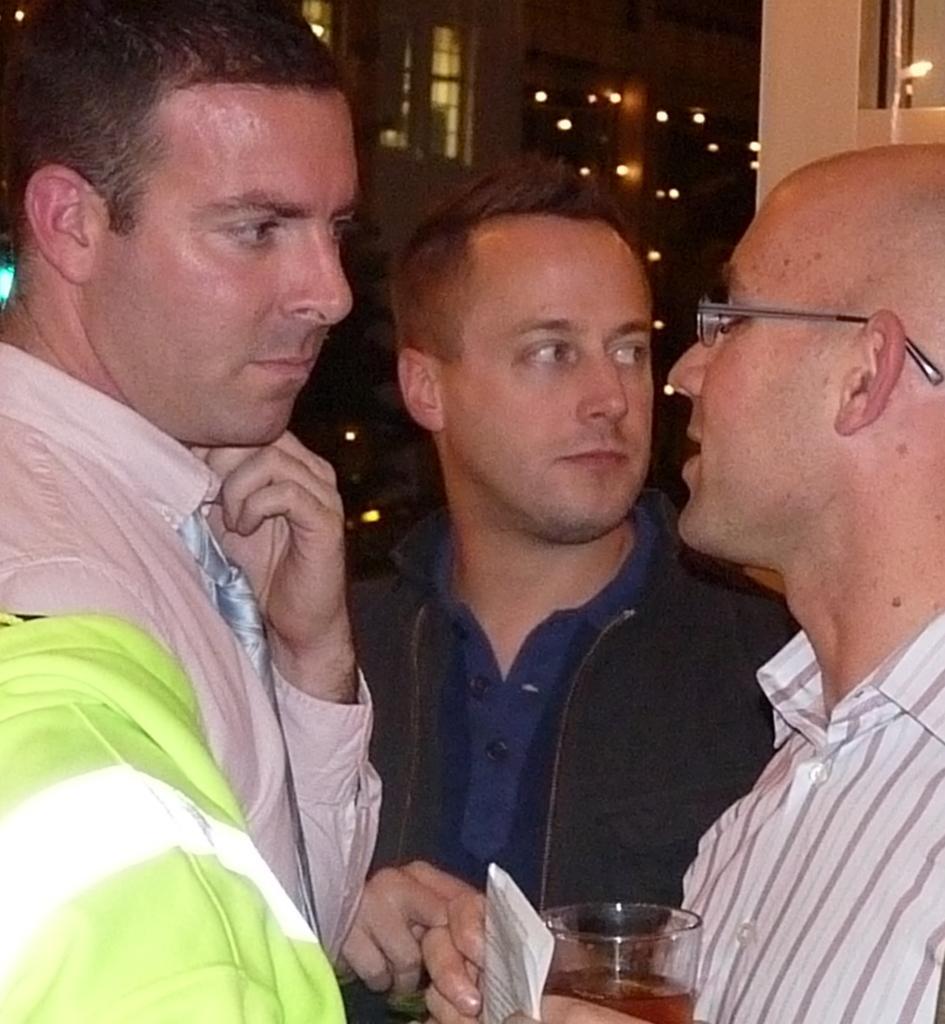Describe this image in one or two sentences. The image is clicked outside the house. There are three men in the image. To the right the man is holding a glass of wine and talking. To the left the man is wearing green color shirt and listening. In the middle the man is wearing blue shirt. 